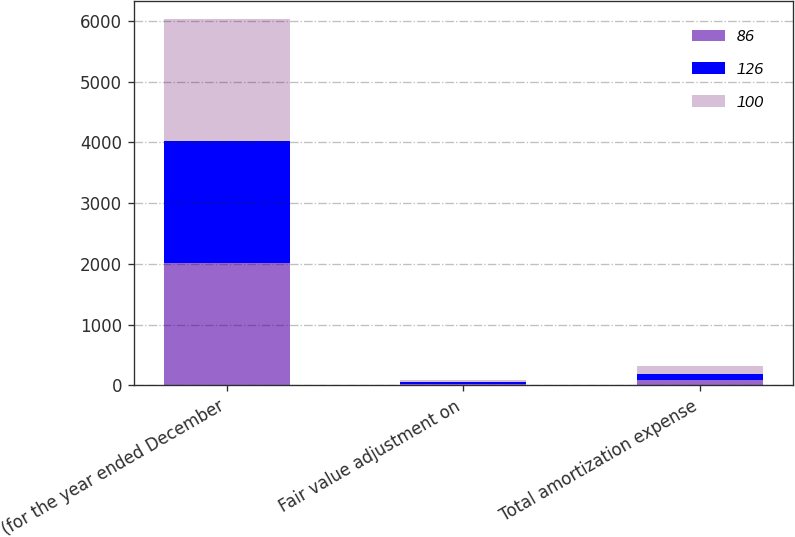Convert chart. <chart><loc_0><loc_0><loc_500><loc_500><stacked_bar_chart><ecel><fcel>(for the year ended December<fcel>Fair value adjustment on<fcel>Total amortization expense<nl><fcel>86<fcel>2010<fcel>25<fcel>86<nl><fcel>126<fcel>2009<fcel>28<fcel>100<nl><fcel>100<fcel>2008<fcel>30<fcel>126<nl></chart> 